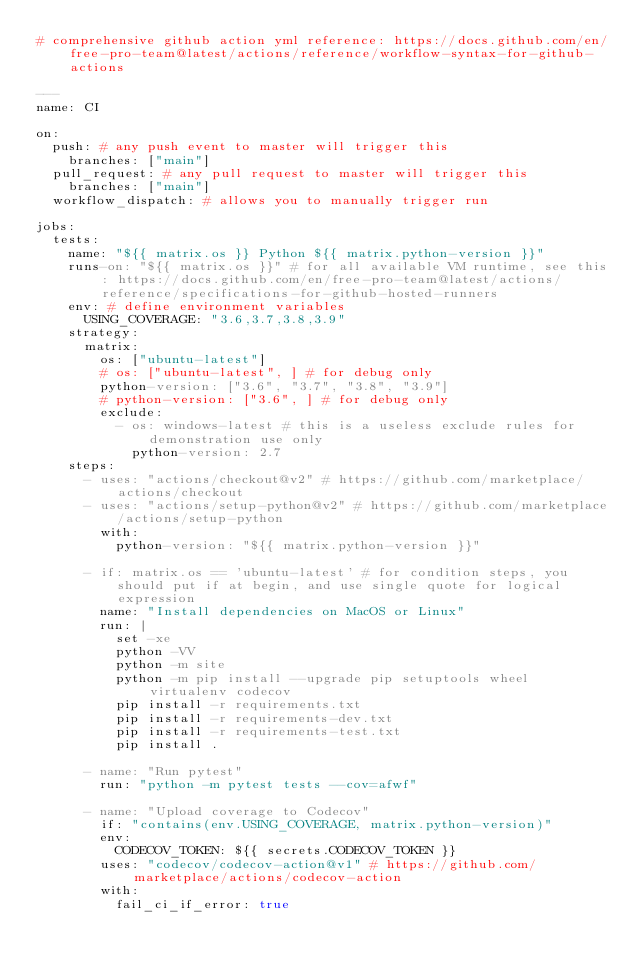Convert code to text. <code><loc_0><loc_0><loc_500><loc_500><_YAML_># comprehensive github action yml reference: https://docs.github.com/en/free-pro-team@latest/actions/reference/workflow-syntax-for-github-actions

---
name: CI

on:
  push: # any push event to master will trigger this
    branches: ["main"]
  pull_request: # any pull request to master will trigger this
    branches: ["main"]
  workflow_dispatch: # allows you to manually trigger run

jobs:
  tests:
    name: "${{ matrix.os }} Python ${{ matrix.python-version }}"
    runs-on: "${{ matrix.os }}" # for all available VM runtime, see this: https://docs.github.com/en/free-pro-team@latest/actions/reference/specifications-for-github-hosted-runners
    env: # define environment variables
      USING_COVERAGE: "3.6,3.7,3.8,3.9"
    strategy:
      matrix:
        os: ["ubuntu-latest"]
        # os: ["ubuntu-latest", ] # for debug only
        python-version: ["3.6", "3.7", "3.8", "3.9"]
        # python-version: ["3.6", ] # for debug only
        exclude:
          - os: windows-latest # this is a useless exclude rules for demonstration use only
            python-version: 2.7
    steps:
      - uses: "actions/checkout@v2" # https://github.com/marketplace/actions/checkout
      - uses: "actions/setup-python@v2" # https://github.com/marketplace/actions/setup-python
        with:
          python-version: "${{ matrix.python-version }}"

      - if: matrix.os == 'ubuntu-latest' # for condition steps, you should put if at begin, and use single quote for logical expression
        name: "Install dependencies on MacOS or Linux"
        run: |
          set -xe
          python -VV
          python -m site
          python -m pip install --upgrade pip setuptools wheel virtualenv codecov
          pip install -r requirements.txt
          pip install -r requirements-dev.txt
          pip install -r requirements-test.txt
          pip install .

      - name: "Run pytest"
        run: "python -m pytest tests --cov=afwf"

      - name: "Upload coverage to Codecov"
        if: "contains(env.USING_COVERAGE, matrix.python-version)"
        env:
          CODECOV_TOKEN: ${{ secrets.CODECOV_TOKEN }}
        uses: "codecov/codecov-action@v1" # https://github.com/marketplace/actions/codecov-action
        with:
          fail_ci_if_error: true
</code> 